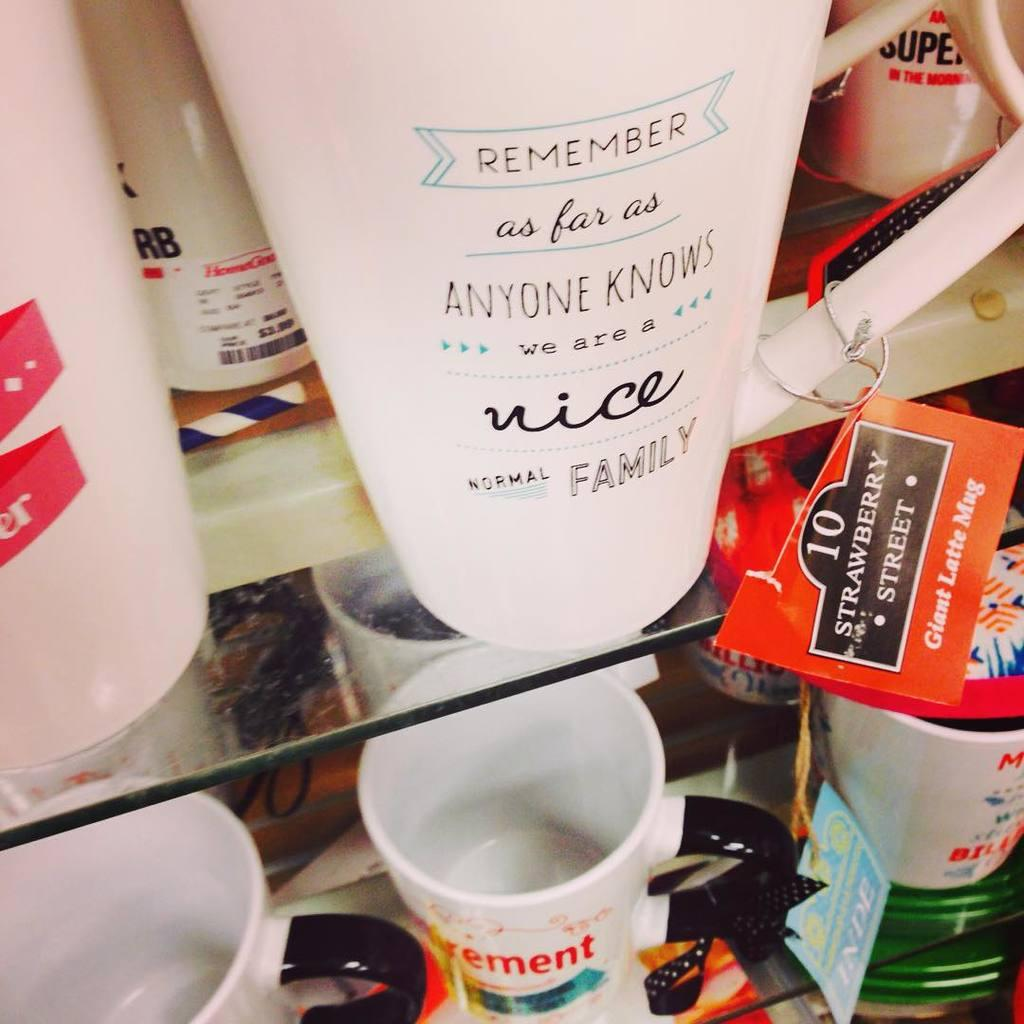<image>
Give a short and clear explanation of the subsequent image. A display of coffee mugs with cheeky phrases on them. 